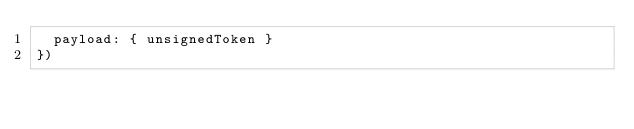Convert code to text. <code><loc_0><loc_0><loc_500><loc_500><_JavaScript_>  payload: { unsignedToken }
})
</code> 